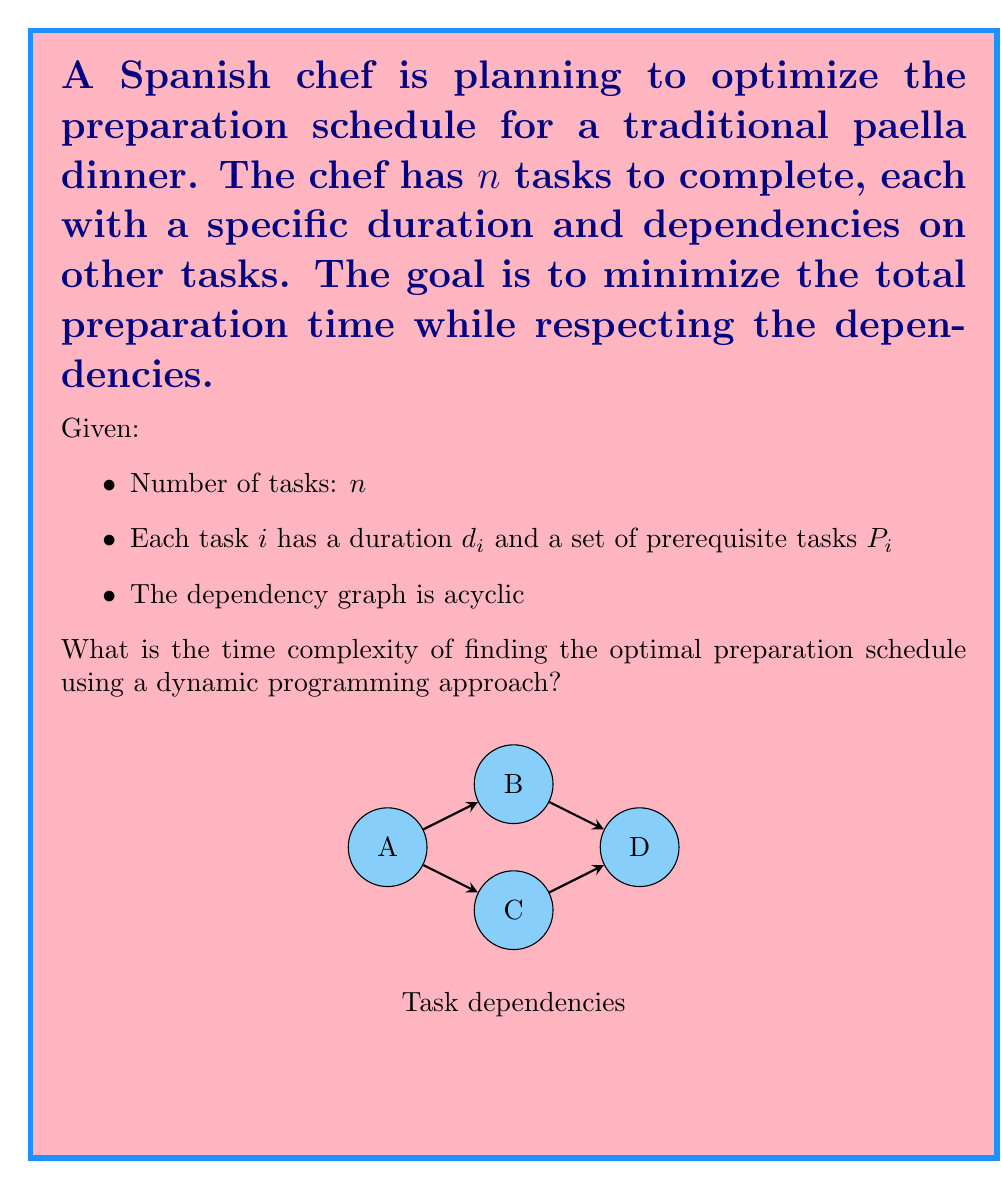What is the answer to this math problem? To solve this problem using dynamic programming, we can follow these steps:

1) First, we need to topologically sort the tasks based on their dependencies. This ensures that we process tasks in an order that respects the prerequisites. Topological sorting takes $O(n + e)$ time, where $e$ is the number of edges in the dependency graph.

2) After sorting, we create a dynamic programming table DP, where DP[i] represents the minimum time needed to complete task i and all its prerequisites.

3) For each task i in the topological order:
   a) Find the maximum completion time of its prerequisites:
      $\text{maxPrereqTime} = \max_{j \in P_i} \text{DP}[j]$
   b) Set the completion time for task i:
      $\text{DP}[i] = \text{maxPrereqTime} + d_i$

4) The optimal preparation time will be the maximum value in the DP table:
   $\text{optimalTime} = \max_{i=1}^n \text{DP}[i]$

Time complexity analysis:
- Topological sorting: $O(n + e)$
- Creating and filling the DP table: $O(n + e)$
  (We visit each task once and check all its prerequisites)
- Finding the maximum in DP: $O(n)$

The total time complexity is $O(n + e)$. In the worst case, where every task depends on every previous task, $e$ could be $O(n^2)$, making the worst-case time complexity $O(n^2)$.

However, in practical cooking scenarios, the dependency graph is usually sparse (each task typically depends on only a few others), so $e$ is often $O(n)$, resulting in an average-case time complexity of $O(n)$.
Answer: $O(n + e)$, where $n$ is the number of tasks and $e$ is the number of dependencies 